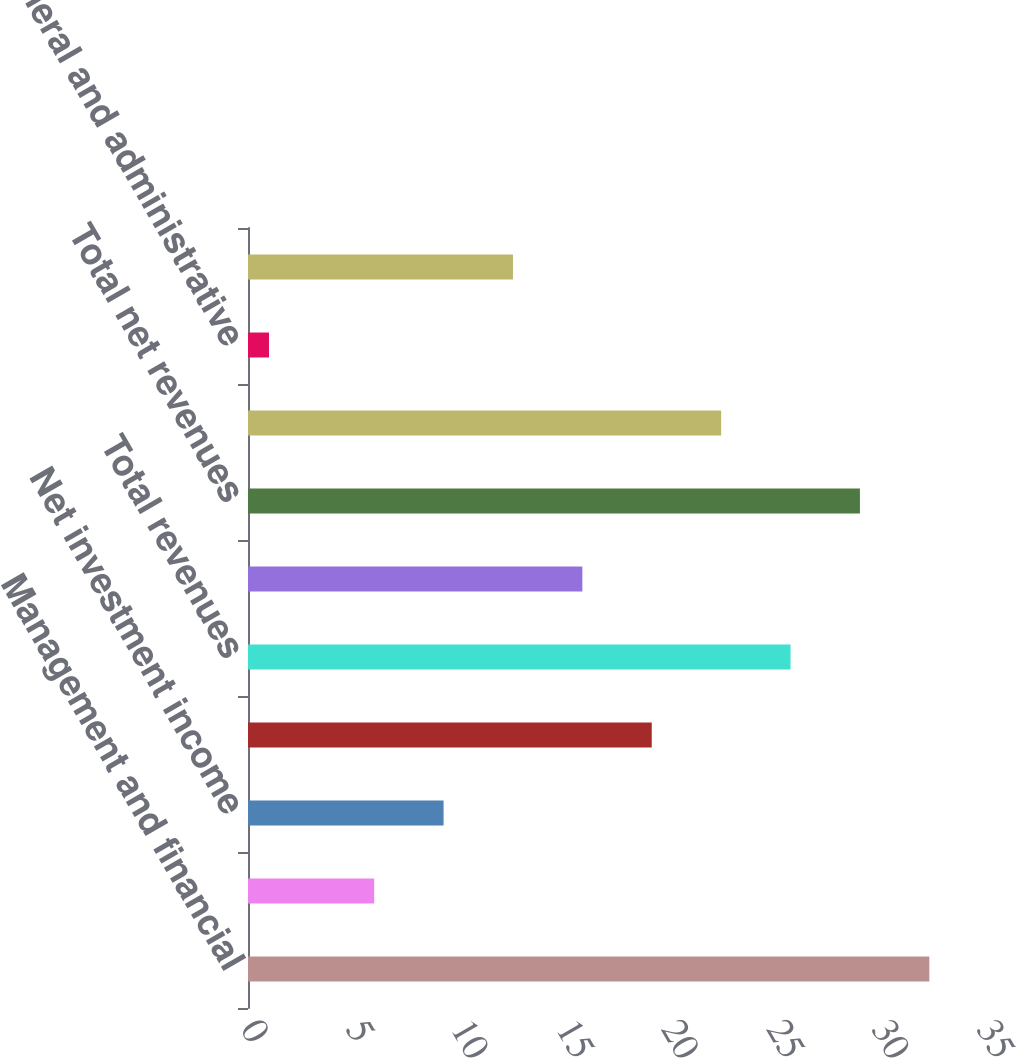Convert chart. <chart><loc_0><loc_0><loc_500><loc_500><bar_chart><fcel>Management and financial<fcel>Distribution fees<fcel>Net investment income<fcel>Other revenues<fcel>Total revenues<fcel>Banking and deposit interest<fcel>Total net revenues<fcel>Distribution expenses<fcel>General and administrative<fcel>Total expenses<nl><fcel>32.4<fcel>6<fcel>9.3<fcel>19.2<fcel>25.8<fcel>15.9<fcel>29.1<fcel>22.5<fcel>1<fcel>12.6<nl></chart> 